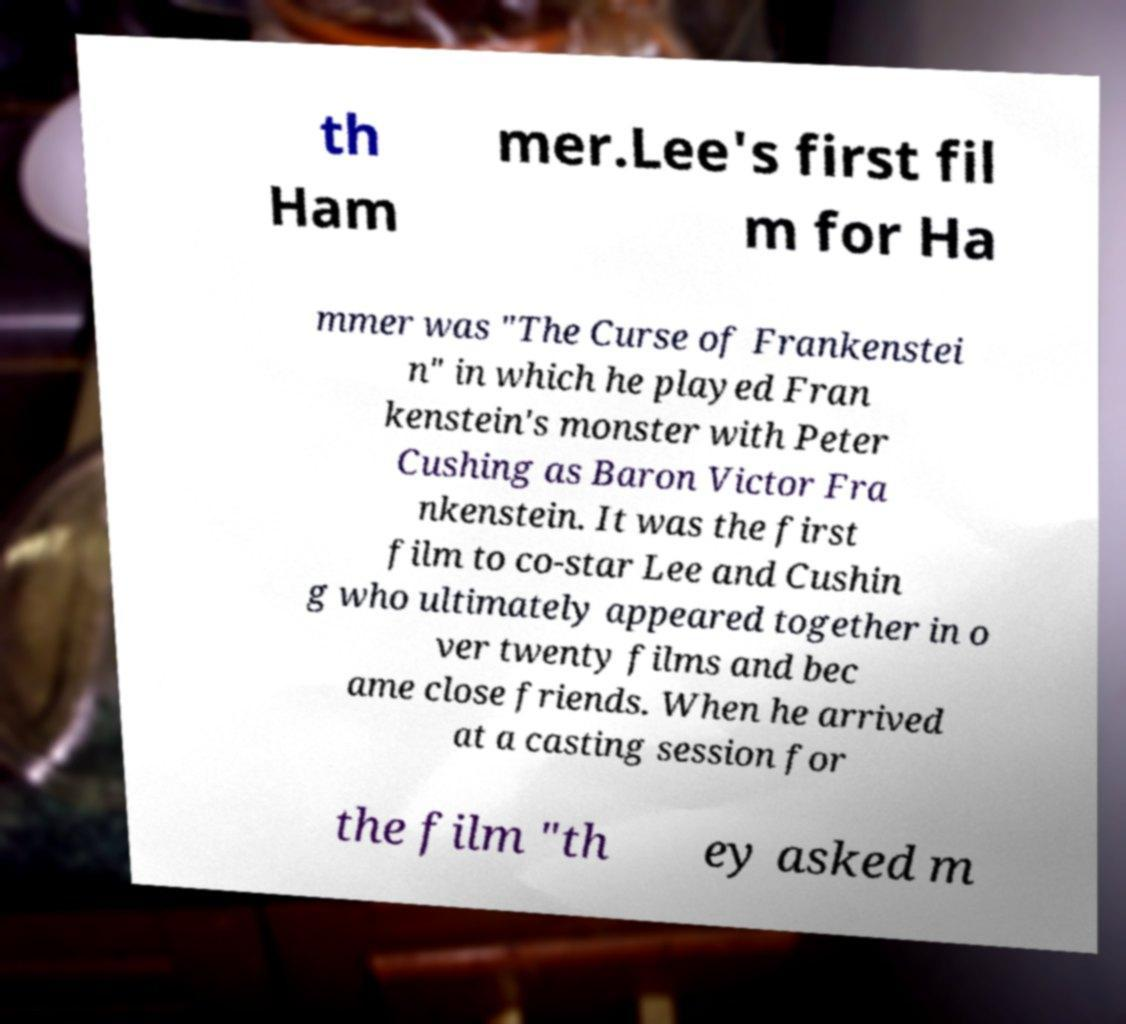Could you assist in decoding the text presented in this image and type it out clearly? th Ham mer.Lee's first fil m for Ha mmer was "The Curse of Frankenstei n" in which he played Fran kenstein's monster with Peter Cushing as Baron Victor Fra nkenstein. It was the first film to co-star Lee and Cushin g who ultimately appeared together in o ver twenty films and bec ame close friends. When he arrived at a casting session for the film "th ey asked m 